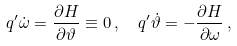Convert formula to latex. <formula><loc_0><loc_0><loc_500><loc_500>& q ^ { \prime } \dot { \omega } = \frac { \partial H } { \partial \vartheta } \equiv 0 \, , \quad q ^ { \prime } \dot { \vartheta } = - \frac { \partial H } { \partial \omega } \ ,</formula> 